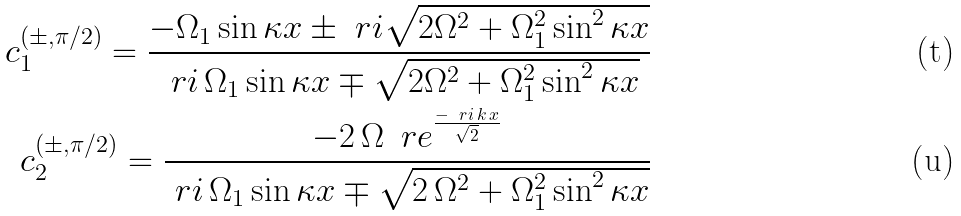<formula> <loc_0><loc_0><loc_500><loc_500>c _ { 1 } ^ { ( \pm , \pi / 2 ) } = \frac { - \Omega _ { 1 } \sin \kappa x \pm \ r i \sqrt { 2 \Omega ^ { 2 } + \Omega _ { 1 } ^ { 2 } \sin ^ { 2 } \kappa x } } { \ r i \, \Omega _ { 1 } \sin \kappa x \mp \sqrt { 2 \Omega ^ { 2 } + \Omega _ { 1 } ^ { 2 } \sin ^ { 2 } \kappa x } } \\ c _ { 2 } ^ { ( \pm , \pi / 2 ) } = \frac { - 2 \, \Omega \, \ r e ^ { \frac { - \ r i \, k \, x } { \sqrt { 2 } } } } { \ r i \, \Omega _ { 1 } \sin \kappa x \mp \sqrt { 2 \, \Omega ^ { 2 } + \Omega _ { 1 } ^ { 2 } \sin ^ { 2 } \kappa x } }</formula> 